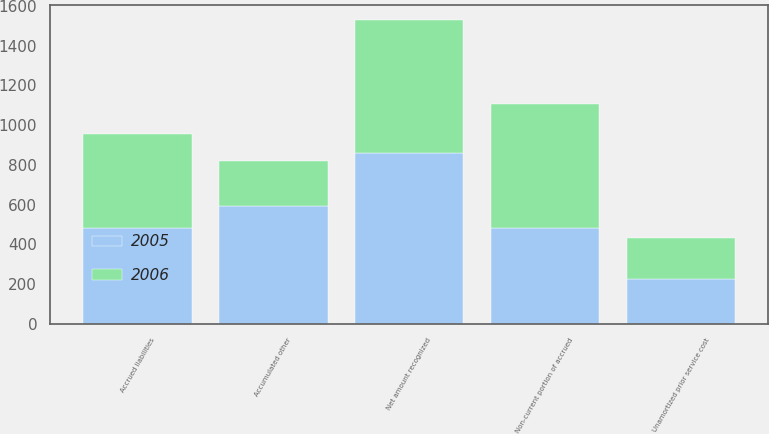<chart> <loc_0><loc_0><loc_500><loc_500><stacked_bar_chart><ecel><fcel>Unamortized prior service cost<fcel>Accrued liabilities<fcel>Non-current portion of accrued<fcel>Accumulated other<fcel>Net amount recognized<nl><fcel>2006<fcel>203<fcel>475<fcel>625<fcel>229<fcel>668<nl><fcel>2005<fcel>227<fcel>480<fcel>480<fcel>591<fcel>860<nl></chart> 